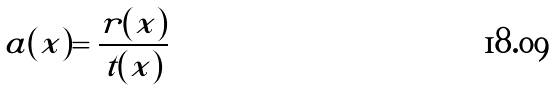<formula> <loc_0><loc_0><loc_500><loc_500>a ( x ) = \frac { r ( x ) } { t ( x ) }</formula> 